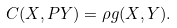Convert formula to latex. <formula><loc_0><loc_0><loc_500><loc_500>C ( X , P Y ) = \rho g ( X , Y ) .</formula> 